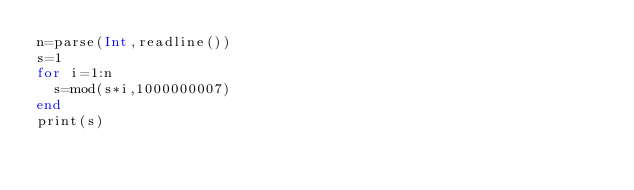<code> <loc_0><loc_0><loc_500><loc_500><_Julia_>n=parse(Int,readline())
s=1
for i=1:n
  s=mod(s*i,1000000007)
end
print(s)</code> 